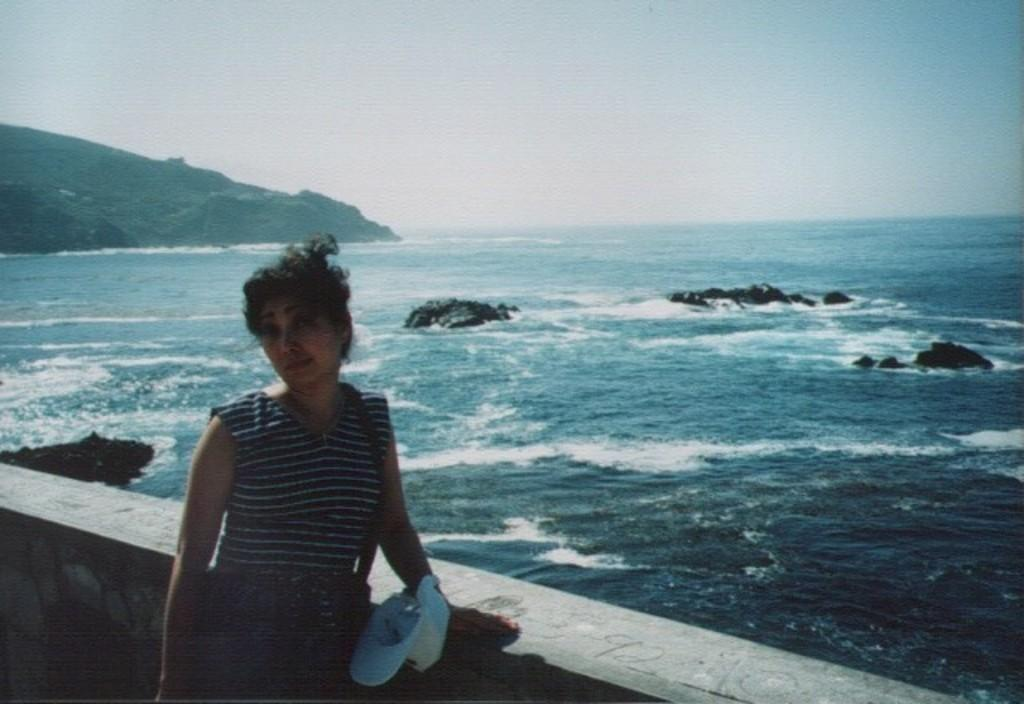What is the woman doing in the image? The woman is standing near the wall in the image. What can be seen behind the wall? There is a water surface visible behind the wall. What is visible in the distance? There is a hill slope visible in the distance. What is visible above the wall and hill slope? The sky is visible in the image. What type of underwear is the woman wearing in the image? There is no information about the woman's underwear in the image, so it cannot be determined. What school is visible in the image? There is no school present in the image. 